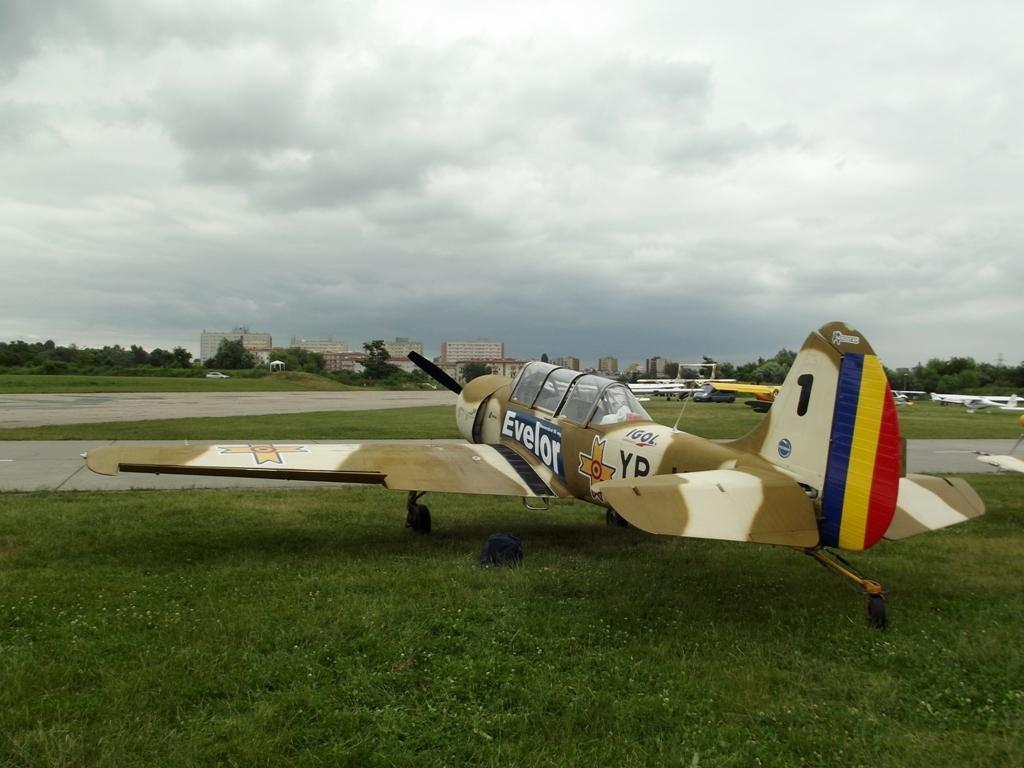What can be seen at the top of the image? The sky with clouds is visible at the top of the image. What type of structures are present in the image? There are buildings in the image. What other natural elements can be seen in the image? Trees are present in the image. What is the purpose of the road visible in the image? The road is visible in the image, likely for transportation purposes. What is the unusual object placed on the ground at the bottom of the image? There is an aeroplane placed on the ground at the bottom of the image. What is the size of the nerve that can be seen in the image? There is no nerve present in the image; it features a sky, buildings, trees, a road, and an aeroplane on the ground. 